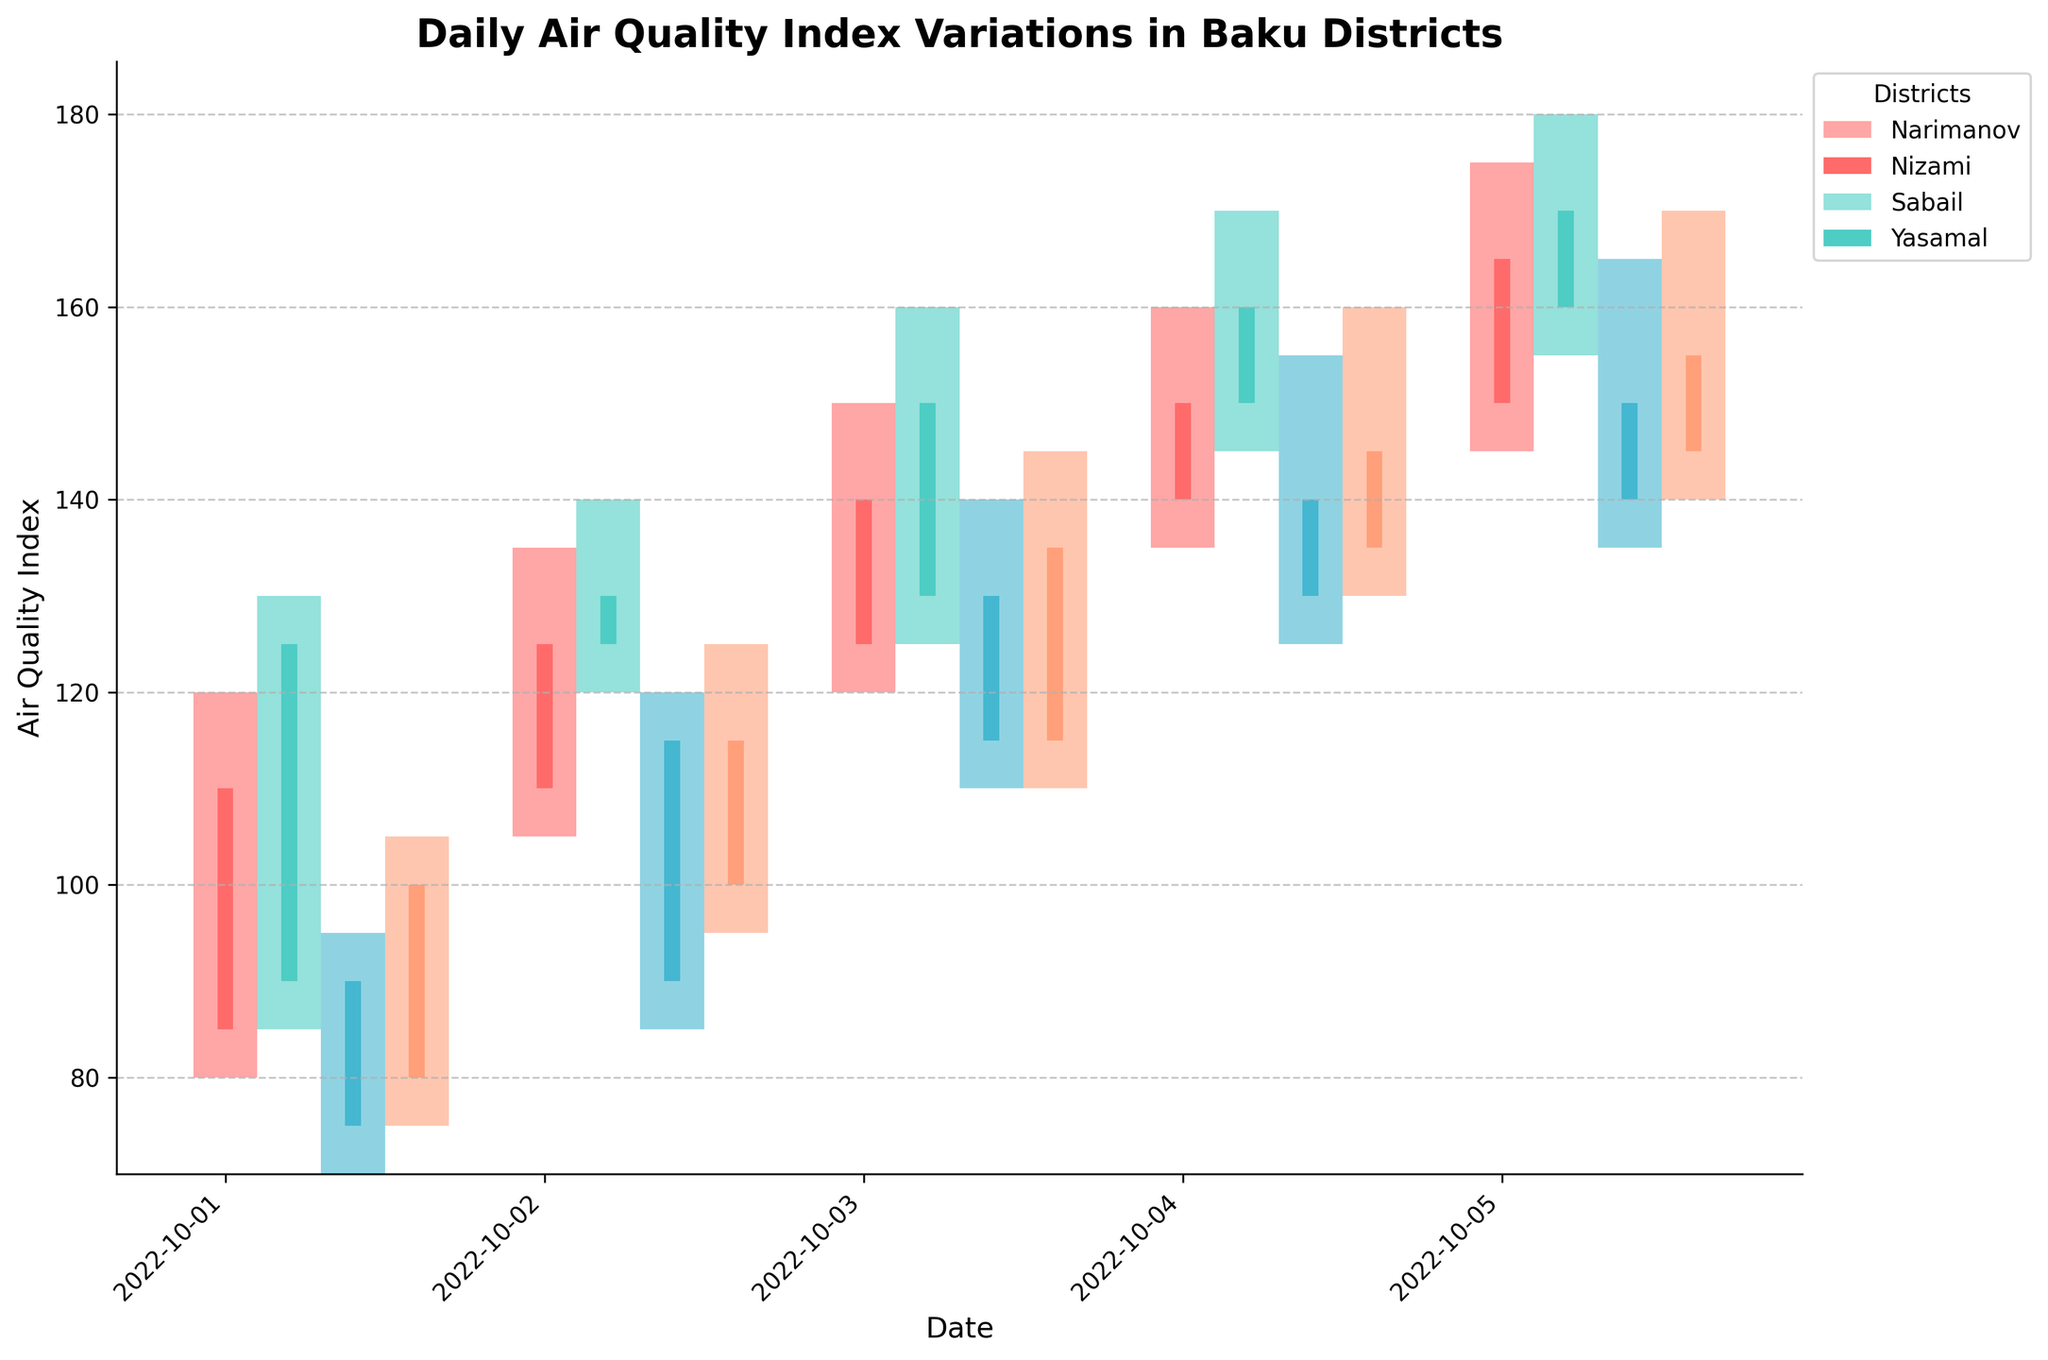What is the title of the plot? The title is usually found at the top of the plot and it gives a brief description of what the plot represents. In this case, it reads "Daily Air Quality Index Variations in Baku Districts"
Answer: Daily Air Quality Index Variations in Baku Districts Which axis displays the air quality index values? Air quality index values are typically displayed on the vertical axis (y-axis) in plots related to numerical values. In this plot, the y-axis shows the variations in air quality index.
Answer: y-axis What are the districts that have their air quality index represented in the plot? The legend on the plot normally indicates the categories represented. In this plot, the legend lists the districts, which are "Narimanov", "Nizami", "Sabail", and "Yasamal".
Answer: Narimanov, Nizami, Sabail, Yasamal What color represents the Narimanov district? The bar colors for each district are defined in the legend. According to the legend, the Narimanov district is represented by the first color.
Answer: A specific color (e.g., red) Which district had the highest air quality index on October 4, 2022? On October 4, 2022, we check the values at the highest point for each district. The district with the highest peak value is Nizami (170).
Answer: Nizami On which date did Sabail reach its highest closing air quality index? We need to look at Sabail's candlesticks and identify the day with the highest closing value. The highest closing value for Sabail (150) occurs on October 5, 2022.
Answer: October 5, 2022 Which two districts had the closest opening air quality index on October 2, 2022? To compare the opening values for all districts on October 2, 2022, we find that Yasamal (100) and Sabail (90) are the closest.
Answer: Yasamal and Sabail What is the range of air quality index values for Yasamal on October 3, 2022? We find the highest and lowest values for Yasamal on October 3, 2022. The range is calculated by subtracting the low value (110) from the high value (145). The difference is 35.
Answer: 35 On which date did the Narimanov district start with an air quality index of 110? By examining the candlestick for Narimanov, we find the opening value of 110 on October 2, 2022.
Answer: October 2, 2022 